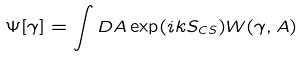Convert formula to latex. <formula><loc_0><loc_0><loc_500><loc_500>\Psi [ \gamma ] = \int D A \exp ( i k S _ { C S } ) W ( \gamma , A )</formula> 